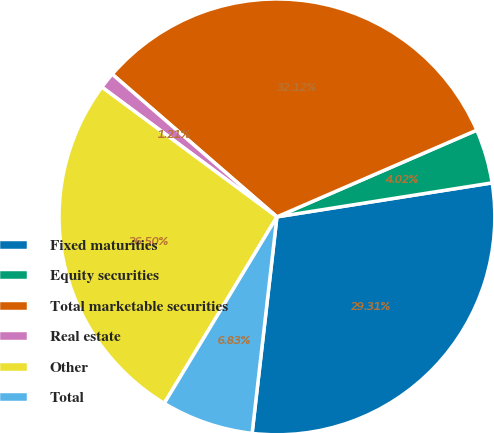<chart> <loc_0><loc_0><loc_500><loc_500><pie_chart><fcel>Fixed maturities<fcel>Equity securities<fcel>Total marketable securities<fcel>Real estate<fcel>Other<fcel>Total<nl><fcel>29.31%<fcel>4.02%<fcel>32.12%<fcel>1.21%<fcel>26.5%<fcel>6.83%<nl></chart> 